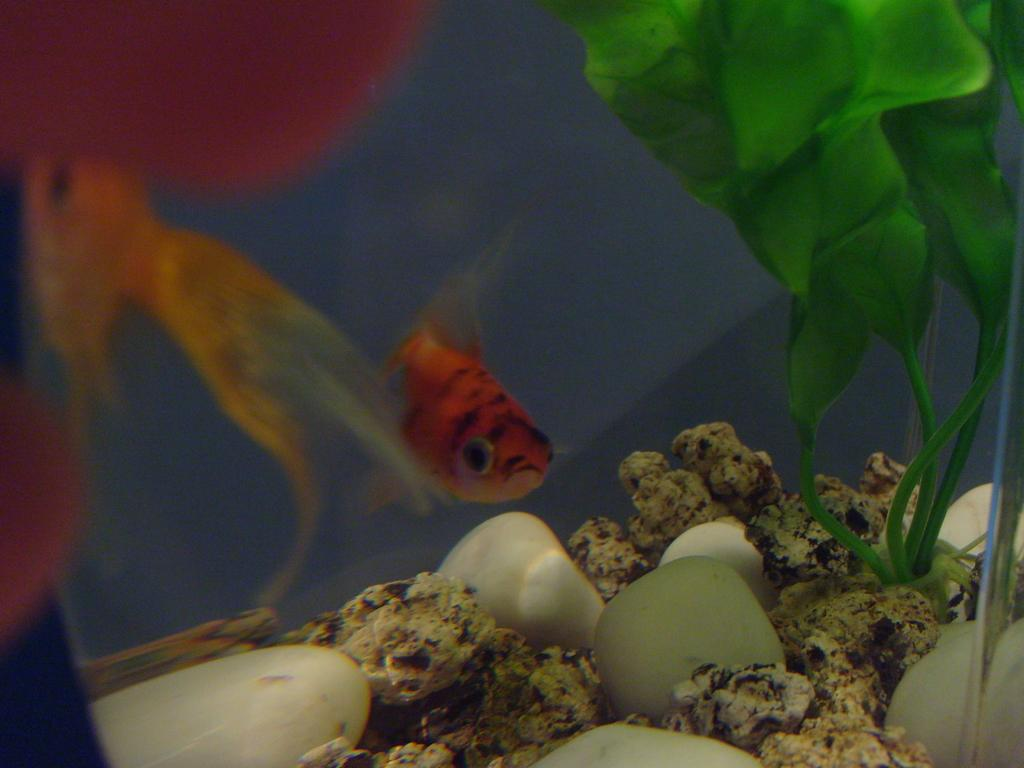What color is the fish in the image? The fish in the image is red. Where is the fish located? The fish is in an aquarium. What can be found at the bottom of the aquarium? There are pebble stones at the bottom of the aquarium. Are there any decorations in the aquarium? Yes, there are artificial plants in the aquarium. How many fishes are in the aquarium? There are other fishes in the aquarium besides the red fish. What type of dinosaur can be seen in the image? There are no dinosaurs present in the image; it features a red fish in an aquarium with pebble stones and artificial plants. 